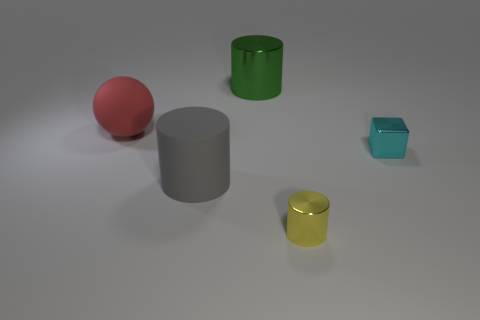Subtract all small metal cylinders. How many cylinders are left? 2 Add 4 tiny cyan shiny cubes. How many objects exist? 9 Subtract all yellow cylinders. How many cylinders are left? 2 Subtract 1 blocks. How many blocks are left? 0 Subtract all blocks. How many objects are left? 4 Subtract 1 cyan blocks. How many objects are left? 4 Subtract all gray balls. Subtract all gray cylinders. How many balls are left? 1 Subtract all brown spheres. How many brown blocks are left? 0 Subtract all metal blocks. Subtract all tiny cyan cubes. How many objects are left? 3 Add 1 big spheres. How many big spheres are left? 2 